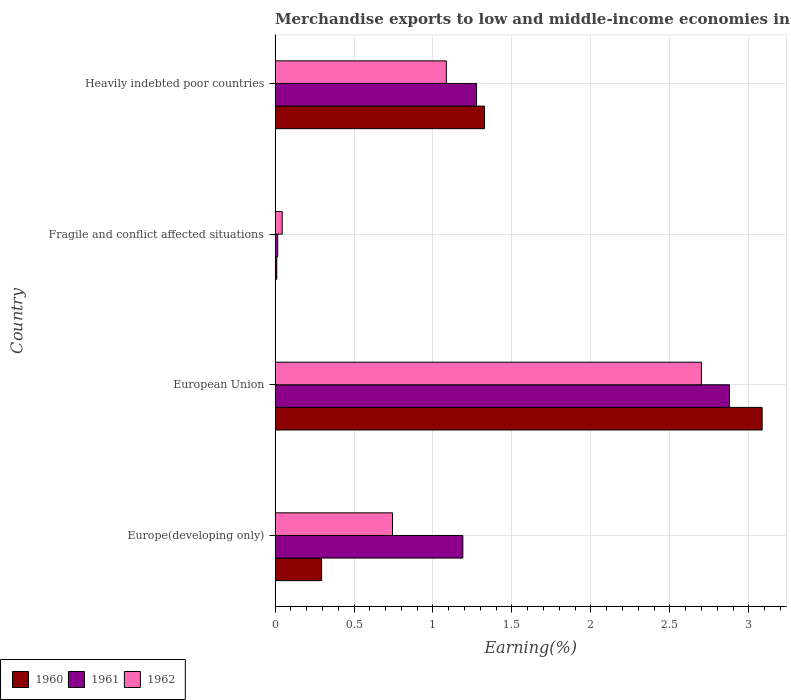How many groups of bars are there?
Give a very brief answer. 4. Are the number of bars on each tick of the Y-axis equal?
Provide a succinct answer. Yes. What is the label of the 4th group of bars from the top?
Your answer should be very brief. Europe(developing only). In how many cases, is the number of bars for a given country not equal to the number of legend labels?
Offer a terse response. 0. What is the percentage of amount earned from merchandise exports in 1960 in European Union?
Your answer should be very brief. 3.08. Across all countries, what is the maximum percentage of amount earned from merchandise exports in 1960?
Give a very brief answer. 3.08. Across all countries, what is the minimum percentage of amount earned from merchandise exports in 1962?
Provide a short and direct response. 0.05. In which country was the percentage of amount earned from merchandise exports in 1961 minimum?
Make the answer very short. Fragile and conflict affected situations. What is the total percentage of amount earned from merchandise exports in 1962 in the graph?
Make the answer very short. 4.57. What is the difference between the percentage of amount earned from merchandise exports in 1961 in European Union and that in Fragile and conflict affected situations?
Make the answer very short. 2.86. What is the difference between the percentage of amount earned from merchandise exports in 1960 in Europe(developing only) and the percentage of amount earned from merchandise exports in 1962 in Fragile and conflict affected situations?
Offer a very short reply. 0.25. What is the average percentage of amount earned from merchandise exports in 1960 per country?
Make the answer very short. 1.18. What is the difference between the percentage of amount earned from merchandise exports in 1960 and percentage of amount earned from merchandise exports in 1961 in Heavily indebted poor countries?
Provide a short and direct response. 0.05. What is the ratio of the percentage of amount earned from merchandise exports in 1962 in Europe(developing only) to that in European Union?
Keep it short and to the point. 0.28. What is the difference between the highest and the second highest percentage of amount earned from merchandise exports in 1962?
Keep it short and to the point. 1.62. What is the difference between the highest and the lowest percentage of amount earned from merchandise exports in 1960?
Your answer should be very brief. 3.07. What does the 1st bar from the top in European Union represents?
Your response must be concise. 1962. What does the 1st bar from the bottom in Heavily indebted poor countries represents?
Offer a very short reply. 1960. What is the difference between two consecutive major ticks on the X-axis?
Your response must be concise. 0.5. Does the graph contain any zero values?
Provide a succinct answer. No. Does the graph contain grids?
Provide a short and direct response. Yes. How many legend labels are there?
Provide a short and direct response. 3. How are the legend labels stacked?
Give a very brief answer. Horizontal. What is the title of the graph?
Offer a very short reply. Merchandise exports to low and middle-income economies in Latin America. Does "1975" appear as one of the legend labels in the graph?
Give a very brief answer. No. What is the label or title of the X-axis?
Offer a very short reply. Earning(%). What is the label or title of the Y-axis?
Your answer should be compact. Country. What is the Earning(%) in 1960 in Europe(developing only)?
Make the answer very short. 0.29. What is the Earning(%) in 1961 in Europe(developing only)?
Keep it short and to the point. 1.19. What is the Earning(%) of 1962 in Europe(developing only)?
Offer a very short reply. 0.74. What is the Earning(%) of 1960 in European Union?
Provide a succinct answer. 3.08. What is the Earning(%) in 1961 in European Union?
Provide a succinct answer. 2.88. What is the Earning(%) of 1962 in European Union?
Your answer should be compact. 2.7. What is the Earning(%) of 1960 in Fragile and conflict affected situations?
Your response must be concise. 0.01. What is the Earning(%) in 1961 in Fragile and conflict affected situations?
Offer a very short reply. 0.02. What is the Earning(%) in 1962 in Fragile and conflict affected situations?
Your response must be concise. 0.05. What is the Earning(%) in 1960 in Heavily indebted poor countries?
Offer a terse response. 1.33. What is the Earning(%) of 1961 in Heavily indebted poor countries?
Offer a very short reply. 1.28. What is the Earning(%) of 1962 in Heavily indebted poor countries?
Your answer should be compact. 1.08. Across all countries, what is the maximum Earning(%) in 1960?
Offer a very short reply. 3.08. Across all countries, what is the maximum Earning(%) of 1961?
Offer a terse response. 2.88. Across all countries, what is the maximum Earning(%) in 1962?
Keep it short and to the point. 2.7. Across all countries, what is the minimum Earning(%) in 1960?
Your answer should be compact. 0.01. Across all countries, what is the minimum Earning(%) in 1961?
Give a very brief answer. 0.02. Across all countries, what is the minimum Earning(%) in 1962?
Ensure brevity in your answer.  0.05. What is the total Earning(%) in 1960 in the graph?
Give a very brief answer. 4.72. What is the total Earning(%) of 1961 in the graph?
Your answer should be very brief. 5.36. What is the total Earning(%) of 1962 in the graph?
Ensure brevity in your answer.  4.57. What is the difference between the Earning(%) in 1960 in Europe(developing only) and that in European Union?
Offer a very short reply. -2.79. What is the difference between the Earning(%) of 1961 in Europe(developing only) and that in European Union?
Offer a terse response. -1.69. What is the difference between the Earning(%) in 1962 in Europe(developing only) and that in European Union?
Offer a very short reply. -1.96. What is the difference between the Earning(%) of 1960 in Europe(developing only) and that in Fragile and conflict affected situations?
Your response must be concise. 0.28. What is the difference between the Earning(%) in 1961 in Europe(developing only) and that in Fragile and conflict affected situations?
Make the answer very short. 1.17. What is the difference between the Earning(%) in 1962 in Europe(developing only) and that in Fragile and conflict affected situations?
Provide a short and direct response. 0.7. What is the difference between the Earning(%) of 1960 in Europe(developing only) and that in Heavily indebted poor countries?
Offer a terse response. -1.03. What is the difference between the Earning(%) of 1961 in Europe(developing only) and that in Heavily indebted poor countries?
Your answer should be compact. -0.09. What is the difference between the Earning(%) of 1962 in Europe(developing only) and that in Heavily indebted poor countries?
Provide a succinct answer. -0.34. What is the difference between the Earning(%) in 1960 in European Union and that in Fragile and conflict affected situations?
Give a very brief answer. 3.07. What is the difference between the Earning(%) in 1961 in European Union and that in Fragile and conflict affected situations?
Your response must be concise. 2.86. What is the difference between the Earning(%) in 1962 in European Union and that in Fragile and conflict affected situations?
Keep it short and to the point. 2.65. What is the difference between the Earning(%) in 1960 in European Union and that in Heavily indebted poor countries?
Ensure brevity in your answer.  1.76. What is the difference between the Earning(%) of 1961 in European Union and that in Heavily indebted poor countries?
Your response must be concise. 1.6. What is the difference between the Earning(%) in 1962 in European Union and that in Heavily indebted poor countries?
Ensure brevity in your answer.  1.62. What is the difference between the Earning(%) of 1960 in Fragile and conflict affected situations and that in Heavily indebted poor countries?
Your answer should be compact. -1.32. What is the difference between the Earning(%) of 1961 in Fragile and conflict affected situations and that in Heavily indebted poor countries?
Offer a very short reply. -1.26. What is the difference between the Earning(%) of 1962 in Fragile and conflict affected situations and that in Heavily indebted poor countries?
Offer a very short reply. -1.04. What is the difference between the Earning(%) of 1960 in Europe(developing only) and the Earning(%) of 1961 in European Union?
Provide a short and direct response. -2.58. What is the difference between the Earning(%) in 1960 in Europe(developing only) and the Earning(%) in 1962 in European Union?
Give a very brief answer. -2.41. What is the difference between the Earning(%) in 1961 in Europe(developing only) and the Earning(%) in 1962 in European Union?
Offer a terse response. -1.51. What is the difference between the Earning(%) in 1960 in Europe(developing only) and the Earning(%) in 1961 in Fragile and conflict affected situations?
Make the answer very short. 0.28. What is the difference between the Earning(%) of 1960 in Europe(developing only) and the Earning(%) of 1962 in Fragile and conflict affected situations?
Your answer should be very brief. 0.25. What is the difference between the Earning(%) in 1961 in Europe(developing only) and the Earning(%) in 1962 in Fragile and conflict affected situations?
Provide a succinct answer. 1.14. What is the difference between the Earning(%) in 1960 in Europe(developing only) and the Earning(%) in 1961 in Heavily indebted poor countries?
Keep it short and to the point. -0.98. What is the difference between the Earning(%) of 1960 in Europe(developing only) and the Earning(%) of 1962 in Heavily indebted poor countries?
Ensure brevity in your answer.  -0.79. What is the difference between the Earning(%) in 1961 in Europe(developing only) and the Earning(%) in 1962 in Heavily indebted poor countries?
Offer a terse response. 0.1. What is the difference between the Earning(%) of 1960 in European Union and the Earning(%) of 1961 in Fragile and conflict affected situations?
Your answer should be compact. 3.07. What is the difference between the Earning(%) of 1960 in European Union and the Earning(%) of 1962 in Fragile and conflict affected situations?
Your response must be concise. 3.04. What is the difference between the Earning(%) in 1961 in European Union and the Earning(%) in 1962 in Fragile and conflict affected situations?
Provide a succinct answer. 2.83. What is the difference between the Earning(%) in 1960 in European Union and the Earning(%) in 1961 in Heavily indebted poor countries?
Provide a short and direct response. 1.81. What is the difference between the Earning(%) in 1960 in European Union and the Earning(%) in 1962 in Heavily indebted poor countries?
Keep it short and to the point. 2. What is the difference between the Earning(%) of 1961 in European Union and the Earning(%) of 1962 in Heavily indebted poor countries?
Offer a very short reply. 1.79. What is the difference between the Earning(%) of 1960 in Fragile and conflict affected situations and the Earning(%) of 1961 in Heavily indebted poor countries?
Offer a very short reply. -1.27. What is the difference between the Earning(%) of 1960 in Fragile and conflict affected situations and the Earning(%) of 1962 in Heavily indebted poor countries?
Give a very brief answer. -1.07. What is the difference between the Earning(%) in 1961 in Fragile and conflict affected situations and the Earning(%) in 1962 in Heavily indebted poor countries?
Offer a terse response. -1.07. What is the average Earning(%) in 1960 per country?
Make the answer very short. 1.18. What is the average Earning(%) in 1961 per country?
Your answer should be compact. 1.34. What is the average Earning(%) in 1962 per country?
Ensure brevity in your answer.  1.14. What is the difference between the Earning(%) of 1960 and Earning(%) of 1961 in Europe(developing only)?
Offer a terse response. -0.89. What is the difference between the Earning(%) of 1960 and Earning(%) of 1962 in Europe(developing only)?
Provide a succinct answer. -0.45. What is the difference between the Earning(%) of 1961 and Earning(%) of 1962 in Europe(developing only)?
Your response must be concise. 0.45. What is the difference between the Earning(%) in 1960 and Earning(%) in 1961 in European Union?
Make the answer very short. 0.21. What is the difference between the Earning(%) in 1960 and Earning(%) in 1962 in European Union?
Offer a very short reply. 0.38. What is the difference between the Earning(%) of 1961 and Earning(%) of 1962 in European Union?
Offer a terse response. 0.18. What is the difference between the Earning(%) in 1960 and Earning(%) in 1961 in Fragile and conflict affected situations?
Your answer should be compact. -0.01. What is the difference between the Earning(%) in 1960 and Earning(%) in 1962 in Fragile and conflict affected situations?
Offer a terse response. -0.03. What is the difference between the Earning(%) in 1961 and Earning(%) in 1962 in Fragile and conflict affected situations?
Ensure brevity in your answer.  -0.03. What is the difference between the Earning(%) in 1960 and Earning(%) in 1961 in Heavily indebted poor countries?
Your answer should be compact. 0.05. What is the difference between the Earning(%) in 1960 and Earning(%) in 1962 in Heavily indebted poor countries?
Make the answer very short. 0.24. What is the difference between the Earning(%) of 1961 and Earning(%) of 1962 in Heavily indebted poor countries?
Provide a short and direct response. 0.19. What is the ratio of the Earning(%) in 1960 in Europe(developing only) to that in European Union?
Provide a short and direct response. 0.1. What is the ratio of the Earning(%) of 1961 in Europe(developing only) to that in European Union?
Offer a terse response. 0.41. What is the ratio of the Earning(%) in 1962 in Europe(developing only) to that in European Union?
Give a very brief answer. 0.28. What is the ratio of the Earning(%) in 1960 in Europe(developing only) to that in Fragile and conflict affected situations?
Your answer should be very brief. 27.68. What is the ratio of the Earning(%) in 1961 in Europe(developing only) to that in Fragile and conflict affected situations?
Ensure brevity in your answer.  71.45. What is the ratio of the Earning(%) in 1962 in Europe(developing only) to that in Fragile and conflict affected situations?
Offer a very short reply. 16.47. What is the ratio of the Earning(%) of 1960 in Europe(developing only) to that in Heavily indebted poor countries?
Your response must be concise. 0.22. What is the ratio of the Earning(%) of 1961 in Europe(developing only) to that in Heavily indebted poor countries?
Make the answer very short. 0.93. What is the ratio of the Earning(%) of 1962 in Europe(developing only) to that in Heavily indebted poor countries?
Your response must be concise. 0.69. What is the ratio of the Earning(%) of 1960 in European Union to that in Fragile and conflict affected situations?
Make the answer very short. 289.8. What is the ratio of the Earning(%) in 1961 in European Union to that in Fragile and conflict affected situations?
Offer a terse response. 172.89. What is the ratio of the Earning(%) in 1962 in European Union to that in Fragile and conflict affected situations?
Offer a very short reply. 59.81. What is the ratio of the Earning(%) of 1960 in European Union to that in Heavily indebted poor countries?
Provide a short and direct response. 2.33. What is the ratio of the Earning(%) in 1961 in European Union to that in Heavily indebted poor countries?
Your response must be concise. 2.25. What is the ratio of the Earning(%) of 1962 in European Union to that in Heavily indebted poor countries?
Provide a short and direct response. 2.49. What is the ratio of the Earning(%) in 1960 in Fragile and conflict affected situations to that in Heavily indebted poor countries?
Offer a terse response. 0.01. What is the ratio of the Earning(%) of 1961 in Fragile and conflict affected situations to that in Heavily indebted poor countries?
Your answer should be compact. 0.01. What is the ratio of the Earning(%) of 1962 in Fragile and conflict affected situations to that in Heavily indebted poor countries?
Give a very brief answer. 0.04. What is the difference between the highest and the second highest Earning(%) of 1960?
Make the answer very short. 1.76. What is the difference between the highest and the second highest Earning(%) in 1961?
Your response must be concise. 1.6. What is the difference between the highest and the second highest Earning(%) of 1962?
Your answer should be very brief. 1.62. What is the difference between the highest and the lowest Earning(%) of 1960?
Give a very brief answer. 3.07. What is the difference between the highest and the lowest Earning(%) in 1961?
Your answer should be compact. 2.86. What is the difference between the highest and the lowest Earning(%) of 1962?
Provide a short and direct response. 2.65. 